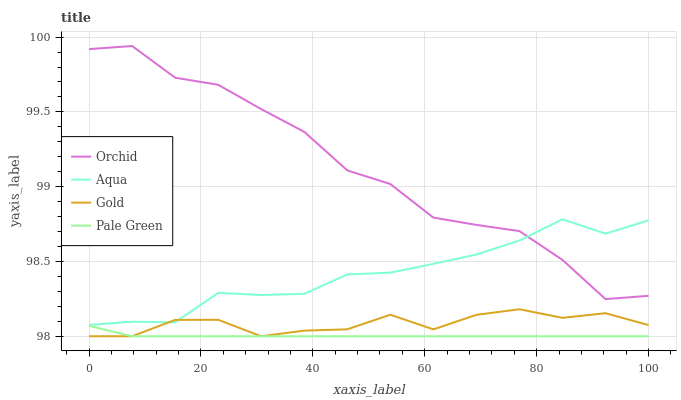Does Pale Green have the minimum area under the curve?
Answer yes or no. Yes. Does Orchid have the maximum area under the curve?
Answer yes or no. Yes. Does Aqua have the minimum area under the curve?
Answer yes or no. No. Does Aqua have the maximum area under the curve?
Answer yes or no. No. Is Pale Green the smoothest?
Answer yes or no. Yes. Is Orchid the roughest?
Answer yes or no. Yes. Is Aqua the smoothest?
Answer yes or no. No. Is Aqua the roughest?
Answer yes or no. No. Does Pale Green have the lowest value?
Answer yes or no. Yes. Does Aqua have the lowest value?
Answer yes or no. No. Does Orchid have the highest value?
Answer yes or no. Yes. Does Aqua have the highest value?
Answer yes or no. No. Is Pale Green less than Aqua?
Answer yes or no. Yes. Is Orchid greater than Pale Green?
Answer yes or no. Yes. Does Gold intersect Pale Green?
Answer yes or no. Yes. Is Gold less than Pale Green?
Answer yes or no. No. Is Gold greater than Pale Green?
Answer yes or no. No. Does Pale Green intersect Aqua?
Answer yes or no. No. 